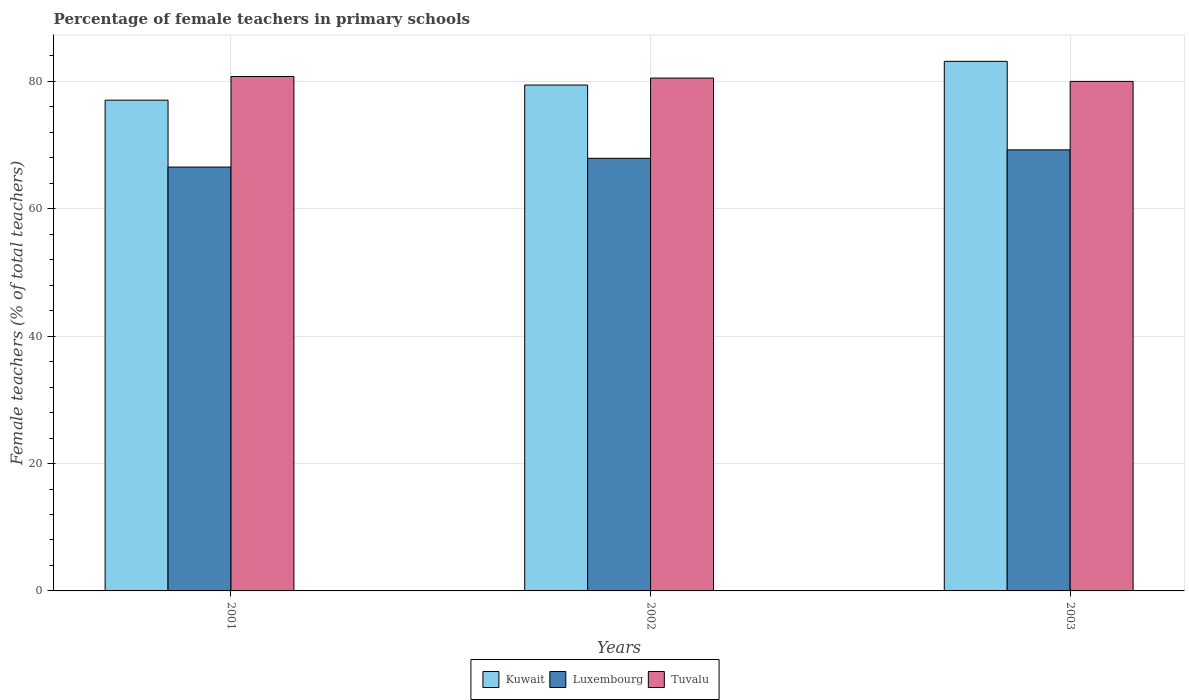How many groups of bars are there?
Provide a succinct answer. 3. Are the number of bars per tick equal to the number of legend labels?
Your answer should be very brief. Yes. Are the number of bars on each tick of the X-axis equal?
Your response must be concise. Yes. How many bars are there on the 2nd tick from the left?
Give a very brief answer. 3. In how many cases, is the number of bars for a given year not equal to the number of legend labels?
Offer a terse response. 0. What is the percentage of female teachers in Kuwait in 2003?
Keep it short and to the point. 83.15. Across all years, what is the maximum percentage of female teachers in Luxembourg?
Your response must be concise. 69.25. Across all years, what is the minimum percentage of female teachers in Luxembourg?
Provide a short and direct response. 66.55. In which year was the percentage of female teachers in Luxembourg maximum?
Your answer should be compact. 2003. What is the total percentage of female teachers in Kuwait in the graph?
Give a very brief answer. 239.62. What is the difference between the percentage of female teachers in Luxembourg in 2001 and that in 2003?
Give a very brief answer. -2.7. What is the difference between the percentage of female teachers in Kuwait in 2003 and the percentage of female teachers in Tuvalu in 2002?
Your answer should be very brief. 2.63. What is the average percentage of female teachers in Tuvalu per year?
Your response must be concise. 80.43. In the year 2003, what is the difference between the percentage of female teachers in Tuvalu and percentage of female teachers in Kuwait?
Offer a very short reply. -3.15. What is the ratio of the percentage of female teachers in Kuwait in 2001 to that in 2003?
Your response must be concise. 0.93. Is the percentage of female teachers in Kuwait in 2001 less than that in 2003?
Keep it short and to the point. Yes. Is the difference between the percentage of female teachers in Tuvalu in 2002 and 2003 greater than the difference between the percentage of female teachers in Kuwait in 2002 and 2003?
Your response must be concise. Yes. What is the difference between the highest and the second highest percentage of female teachers in Tuvalu?
Your answer should be compact. 0.25. What is the difference between the highest and the lowest percentage of female teachers in Kuwait?
Provide a succinct answer. 6.09. In how many years, is the percentage of female teachers in Tuvalu greater than the average percentage of female teachers in Tuvalu taken over all years?
Offer a terse response. 2. Is the sum of the percentage of female teachers in Tuvalu in 2001 and 2002 greater than the maximum percentage of female teachers in Luxembourg across all years?
Offer a very short reply. Yes. What does the 2nd bar from the left in 2003 represents?
Your answer should be compact. Luxembourg. What does the 3rd bar from the right in 2002 represents?
Give a very brief answer. Kuwait. Are all the bars in the graph horizontal?
Your answer should be compact. No. How many years are there in the graph?
Offer a very short reply. 3. What is the difference between two consecutive major ticks on the Y-axis?
Offer a terse response. 20. Are the values on the major ticks of Y-axis written in scientific E-notation?
Offer a very short reply. No. Does the graph contain any zero values?
Make the answer very short. No. What is the title of the graph?
Offer a terse response. Percentage of female teachers in primary schools. What is the label or title of the X-axis?
Ensure brevity in your answer.  Years. What is the label or title of the Y-axis?
Your response must be concise. Female teachers (% of total teachers). What is the Female teachers (% of total teachers) in Kuwait in 2001?
Offer a very short reply. 77.05. What is the Female teachers (% of total teachers) of Luxembourg in 2001?
Offer a very short reply. 66.55. What is the Female teachers (% of total teachers) in Tuvalu in 2001?
Give a very brief answer. 80.77. What is the Female teachers (% of total teachers) of Kuwait in 2002?
Offer a very short reply. 79.42. What is the Female teachers (% of total teachers) of Luxembourg in 2002?
Offer a very short reply. 67.92. What is the Female teachers (% of total teachers) of Tuvalu in 2002?
Provide a short and direct response. 80.52. What is the Female teachers (% of total teachers) in Kuwait in 2003?
Provide a short and direct response. 83.15. What is the Female teachers (% of total teachers) of Luxembourg in 2003?
Your answer should be compact. 69.25. What is the Female teachers (% of total teachers) of Tuvalu in 2003?
Ensure brevity in your answer.  80. Across all years, what is the maximum Female teachers (% of total teachers) of Kuwait?
Your answer should be very brief. 83.15. Across all years, what is the maximum Female teachers (% of total teachers) of Luxembourg?
Provide a short and direct response. 69.25. Across all years, what is the maximum Female teachers (% of total teachers) of Tuvalu?
Keep it short and to the point. 80.77. Across all years, what is the minimum Female teachers (% of total teachers) in Kuwait?
Your answer should be very brief. 77.05. Across all years, what is the minimum Female teachers (% of total teachers) of Luxembourg?
Provide a succinct answer. 66.55. What is the total Female teachers (% of total teachers) in Kuwait in the graph?
Provide a short and direct response. 239.62. What is the total Female teachers (% of total teachers) of Luxembourg in the graph?
Ensure brevity in your answer.  203.72. What is the total Female teachers (% of total teachers) of Tuvalu in the graph?
Offer a very short reply. 241.29. What is the difference between the Female teachers (% of total teachers) of Kuwait in 2001 and that in 2002?
Your response must be concise. -2.37. What is the difference between the Female teachers (% of total teachers) in Luxembourg in 2001 and that in 2002?
Offer a terse response. -1.37. What is the difference between the Female teachers (% of total teachers) in Tuvalu in 2001 and that in 2002?
Offer a terse response. 0.25. What is the difference between the Female teachers (% of total teachers) in Kuwait in 2001 and that in 2003?
Give a very brief answer. -6.09. What is the difference between the Female teachers (% of total teachers) of Luxembourg in 2001 and that in 2003?
Give a very brief answer. -2.7. What is the difference between the Female teachers (% of total teachers) in Tuvalu in 2001 and that in 2003?
Provide a short and direct response. 0.77. What is the difference between the Female teachers (% of total teachers) in Kuwait in 2002 and that in 2003?
Provide a succinct answer. -3.72. What is the difference between the Female teachers (% of total teachers) in Luxembourg in 2002 and that in 2003?
Your answer should be compact. -1.33. What is the difference between the Female teachers (% of total teachers) of Tuvalu in 2002 and that in 2003?
Your answer should be compact. 0.52. What is the difference between the Female teachers (% of total teachers) of Kuwait in 2001 and the Female teachers (% of total teachers) of Luxembourg in 2002?
Your answer should be very brief. 9.13. What is the difference between the Female teachers (% of total teachers) in Kuwait in 2001 and the Female teachers (% of total teachers) in Tuvalu in 2002?
Give a very brief answer. -3.47. What is the difference between the Female teachers (% of total teachers) in Luxembourg in 2001 and the Female teachers (% of total teachers) in Tuvalu in 2002?
Keep it short and to the point. -13.97. What is the difference between the Female teachers (% of total teachers) in Kuwait in 2001 and the Female teachers (% of total teachers) in Luxembourg in 2003?
Offer a terse response. 7.8. What is the difference between the Female teachers (% of total teachers) in Kuwait in 2001 and the Female teachers (% of total teachers) in Tuvalu in 2003?
Offer a terse response. -2.95. What is the difference between the Female teachers (% of total teachers) in Luxembourg in 2001 and the Female teachers (% of total teachers) in Tuvalu in 2003?
Keep it short and to the point. -13.45. What is the difference between the Female teachers (% of total teachers) in Kuwait in 2002 and the Female teachers (% of total teachers) in Luxembourg in 2003?
Your answer should be very brief. 10.17. What is the difference between the Female teachers (% of total teachers) in Kuwait in 2002 and the Female teachers (% of total teachers) in Tuvalu in 2003?
Keep it short and to the point. -0.58. What is the difference between the Female teachers (% of total teachers) of Luxembourg in 2002 and the Female teachers (% of total teachers) of Tuvalu in 2003?
Provide a short and direct response. -12.08. What is the average Female teachers (% of total teachers) of Kuwait per year?
Your answer should be very brief. 79.87. What is the average Female teachers (% of total teachers) in Luxembourg per year?
Your response must be concise. 67.91. What is the average Female teachers (% of total teachers) of Tuvalu per year?
Your answer should be very brief. 80.43. In the year 2001, what is the difference between the Female teachers (% of total teachers) of Kuwait and Female teachers (% of total teachers) of Luxembourg?
Your answer should be compact. 10.5. In the year 2001, what is the difference between the Female teachers (% of total teachers) in Kuwait and Female teachers (% of total teachers) in Tuvalu?
Your answer should be compact. -3.72. In the year 2001, what is the difference between the Female teachers (% of total teachers) of Luxembourg and Female teachers (% of total teachers) of Tuvalu?
Your answer should be compact. -14.22. In the year 2002, what is the difference between the Female teachers (% of total teachers) in Kuwait and Female teachers (% of total teachers) in Luxembourg?
Offer a very short reply. 11.5. In the year 2002, what is the difference between the Female teachers (% of total teachers) of Kuwait and Female teachers (% of total teachers) of Tuvalu?
Offer a very short reply. -1.1. In the year 2002, what is the difference between the Female teachers (% of total teachers) in Luxembourg and Female teachers (% of total teachers) in Tuvalu?
Give a very brief answer. -12.6. In the year 2003, what is the difference between the Female teachers (% of total teachers) of Kuwait and Female teachers (% of total teachers) of Luxembourg?
Your response must be concise. 13.89. In the year 2003, what is the difference between the Female teachers (% of total teachers) in Kuwait and Female teachers (% of total teachers) in Tuvalu?
Give a very brief answer. 3.15. In the year 2003, what is the difference between the Female teachers (% of total teachers) in Luxembourg and Female teachers (% of total teachers) in Tuvalu?
Make the answer very short. -10.75. What is the ratio of the Female teachers (% of total teachers) in Kuwait in 2001 to that in 2002?
Offer a very short reply. 0.97. What is the ratio of the Female teachers (% of total teachers) of Luxembourg in 2001 to that in 2002?
Keep it short and to the point. 0.98. What is the ratio of the Female teachers (% of total teachers) of Tuvalu in 2001 to that in 2002?
Your answer should be compact. 1. What is the ratio of the Female teachers (% of total teachers) in Kuwait in 2001 to that in 2003?
Give a very brief answer. 0.93. What is the ratio of the Female teachers (% of total teachers) of Tuvalu in 2001 to that in 2003?
Offer a terse response. 1.01. What is the ratio of the Female teachers (% of total teachers) in Kuwait in 2002 to that in 2003?
Offer a terse response. 0.96. What is the ratio of the Female teachers (% of total teachers) of Luxembourg in 2002 to that in 2003?
Your answer should be compact. 0.98. What is the difference between the highest and the second highest Female teachers (% of total teachers) of Kuwait?
Offer a very short reply. 3.72. What is the difference between the highest and the second highest Female teachers (% of total teachers) of Luxembourg?
Offer a very short reply. 1.33. What is the difference between the highest and the second highest Female teachers (% of total teachers) in Tuvalu?
Ensure brevity in your answer.  0.25. What is the difference between the highest and the lowest Female teachers (% of total teachers) in Kuwait?
Your answer should be compact. 6.09. What is the difference between the highest and the lowest Female teachers (% of total teachers) of Luxembourg?
Offer a terse response. 2.7. What is the difference between the highest and the lowest Female teachers (% of total teachers) of Tuvalu?
Make the answer very short. 0.77. 